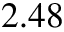<formula> <loc_0><loc_0><loc_500><loc_500>2 . 4 8</formula> 